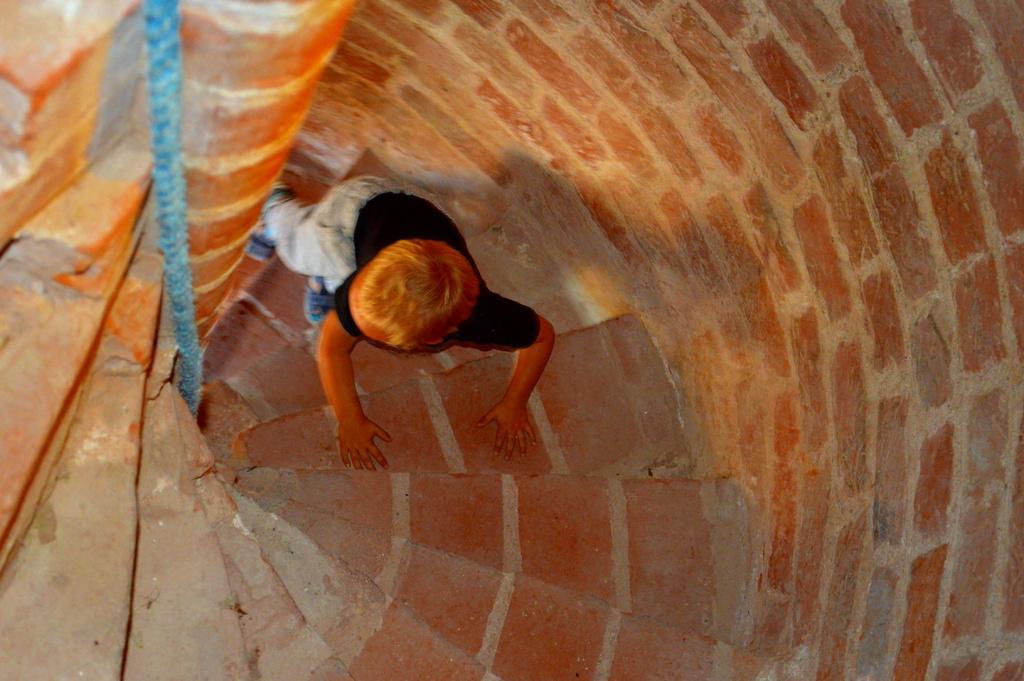Could you give a brief overview of what you see in this image? In this image there is a boy climbing steps beside him there is a brick wall. 